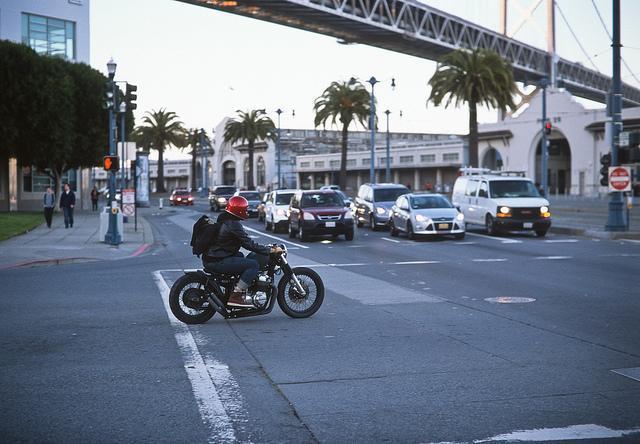How many motorcycles are there?
Give a very brief answer. 1. How many cars can be seen?
Give a very brief answer. 3. 